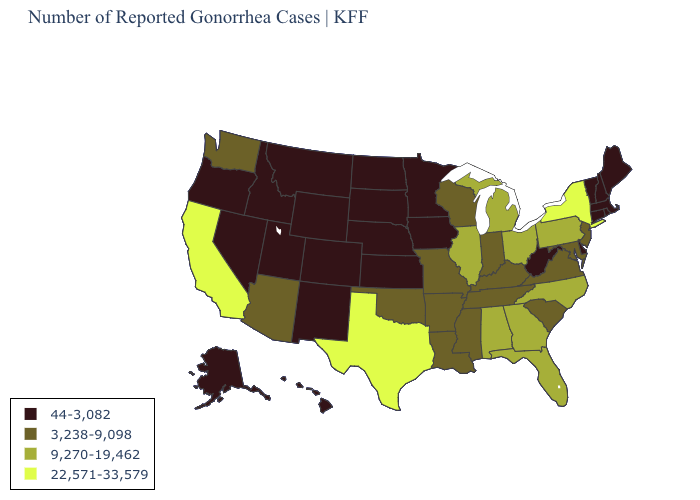What is the value of Alaska?
Be succinct. 44-3,082. Which states hav the highest value in the Northeast?
Concise answer only. New York. What is the value of Florida?
Keep it brief. 9,270-19,462. Name the states that have a value in the range 9,270-19,462?
Concise answer only. Alabama, Florida, Georgia, Illinois, Michigan, North Carolina, Ohio, Pennsylvania. Among the states that border Utah , which have the highest value?
Keep it brief. Arizona. How many symbols are there in the legend?
Short answer required. 4. Among the states that border West Virginia , which have the highest value?
Write a very short answer. Ohio, Pennsylvania. Does the map have missing data?
Write a very short answer. No. Does Florida have the same value as Georgia?
Write a very short answer. Yes. Among the states that border Arkansas , does Texas have the highest value?
Give a very brief answer. Yes. How many symbols are there in the legend?
Write a very short answer. 4. Name the states that have a value in the range 44-3,082?
Quick response, please. Alaska, Colorado, Connecticut, Delaware, Hawaii, Idaho, Iowa, Kansas, Maine, Massachusetts, Minnesota, Montana, Nebraska, Nevada, New Hampshire, New Mexico, North Dakota, Oregon, Rhode Island, South Dakota, Utah, Vermont, West Virginia, Wyoming. Does Nebraska have the highest value in the USA?
Keep it brief. No. Does Michigan have the highest value in the MidWest?
Keep it brief. Yes. Name the states that have a value in the range 9,270-19,462?
Quick response, please. Alabama, Florida, Georgia, Illinois, Michigan, North Carolina, Ohio, Pennsylvania. 